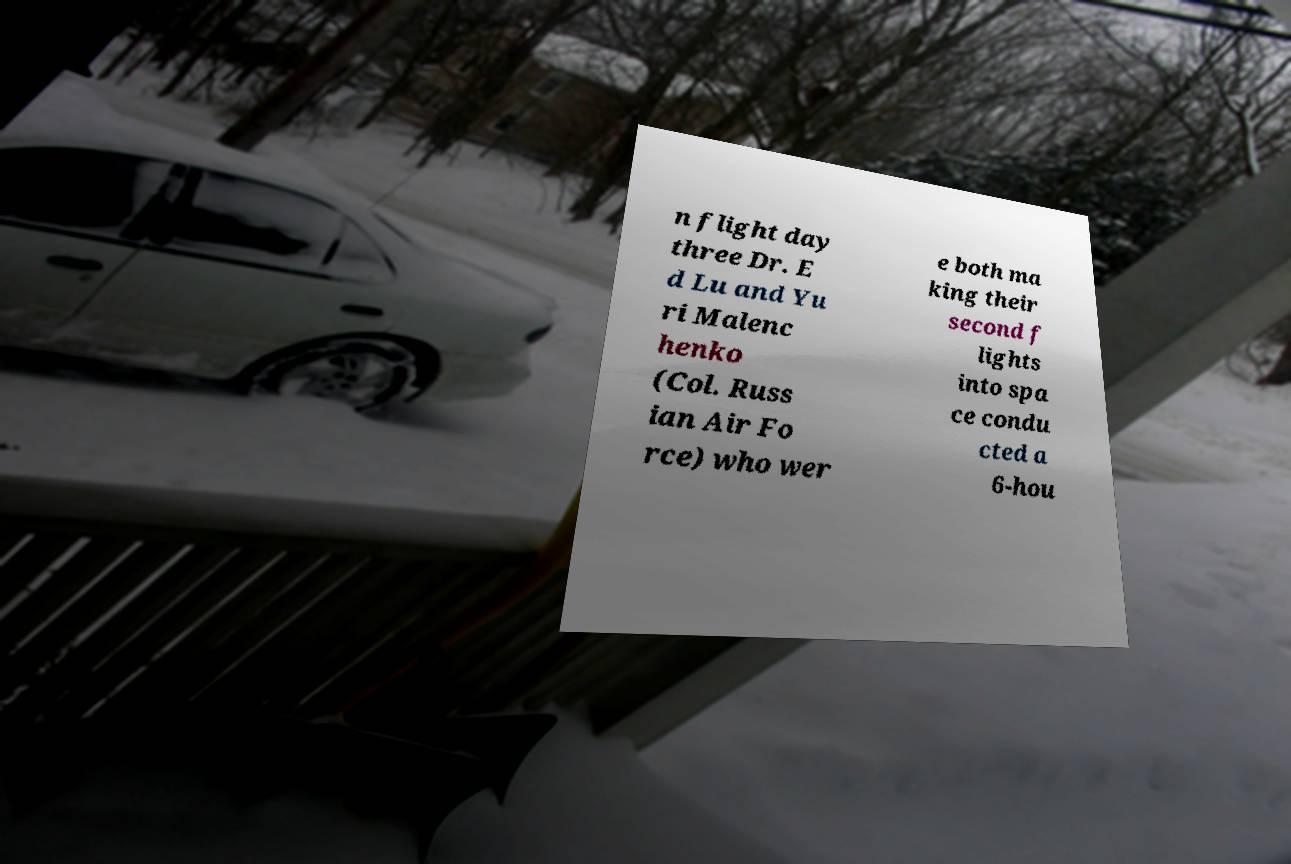Can you accurately transcribe the text from the provided image for me? n flight day three Dr. E d Lu and Yu ri Malenc henko (Col. Russ ian Air Fo rce) who wer e both ma king their second f lights into spa ce condu cted a 6-hou 